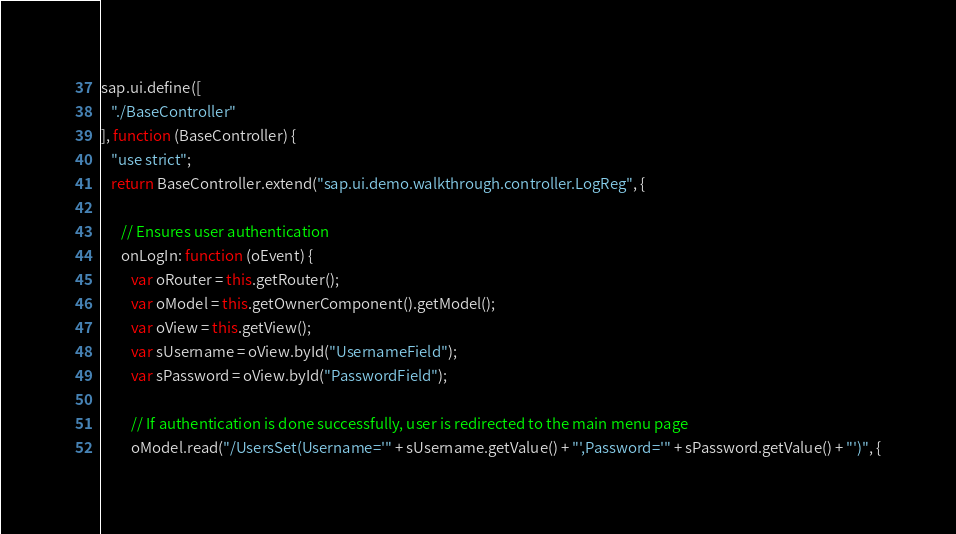<code> <loc_0><loc_0><loc_500><loc_500><_JavaScript_>sap.ui.define([
   "./BaseController"
], function (BaseController) {
   "use strict";
   return BaseController.extend("sap.ui.demo.walkthrough.controller.LogReg", {

      // Ensures user authentication
      onLogIn: function (oEvent) {
         var oRouter = this.getRouter();
         var oModel = this.getOwnerComponent().getModel();
         var oView = this.getView();
         var sUsername = oView.byId("UsernameField");
         var sPassword = oView.byId("PasswordField");

         // If authentication is done successfully, user is redirected to the main menu page
         oModel.read("/UsersSet(Username='" + sUsername.getValue() + "',Password='" + sPassword.getValue() + "')", {</code> 